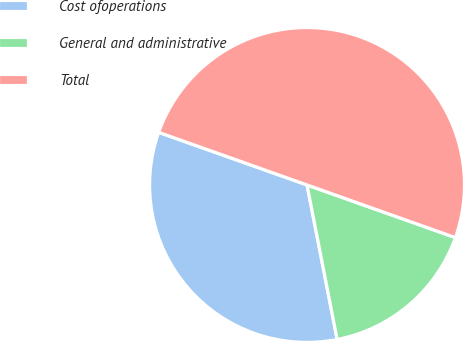Convert chart. <chart><loc_0><loc_0><loc_500><loc_500><pie_chart><fcel>Cost ofoperations<fcel>General and administrative<fcel>Total<nl><fcel>33.49%<fcel>16.51%<fcel>50.0%<nl></chart> 